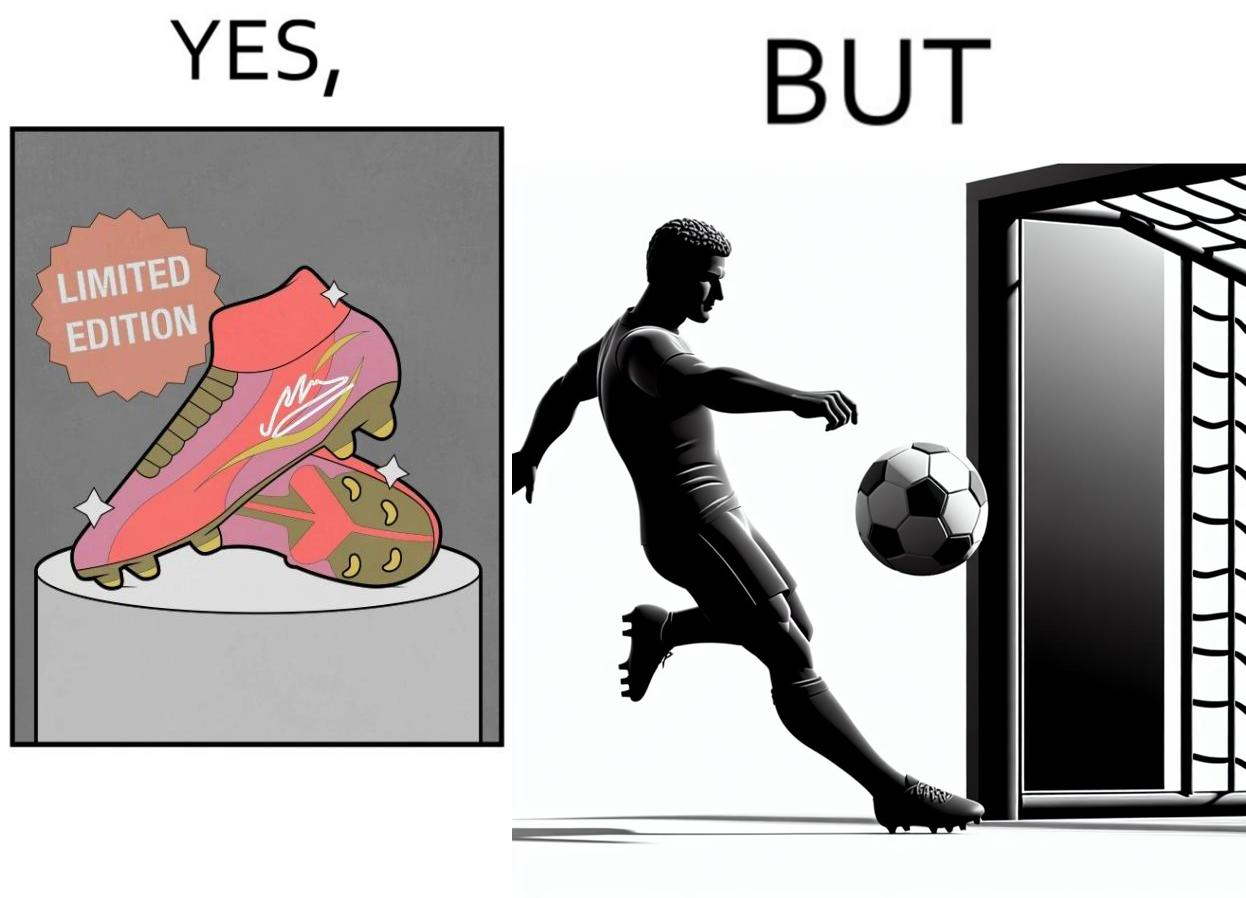Is this a satirical image? Yes, this image is satirical. 